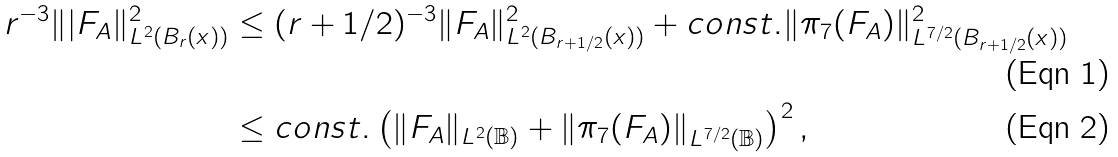<formula> <loc_0><loc_0><loc_500><loc_500>r ^ { - 3 } \| | F _ { A } \| ^ { 2 } _ { L ^ { 2 } ( B _ { r } ( x ) ) } & \leq ( r + 1 / 2 ) ^ { - 3 } \| F _ { A } \| ^ { 2 } _ { L ^ { 2 } ( B _ { r + 1 / 2 } ( x ) ) } + c o n s t . \| \pi _ { 7 } ( F _ { A } ) \| ^ { 2 } _ { L ^ { 7 / 2 } ( B _ { r + 1 / 2 } ( x ) ) } \\ & \leq c o n s t . \left ( \| F _ { A } \| _ { L ^ { 2 } ( \mathbb { B } ) } + \| \pi _ { 7 } ( F _ { A } ) \| _ { L ^ { 7 / 2 } ( \mathbb { B } ) } \right ) ^ { 2 } ,</formula> 